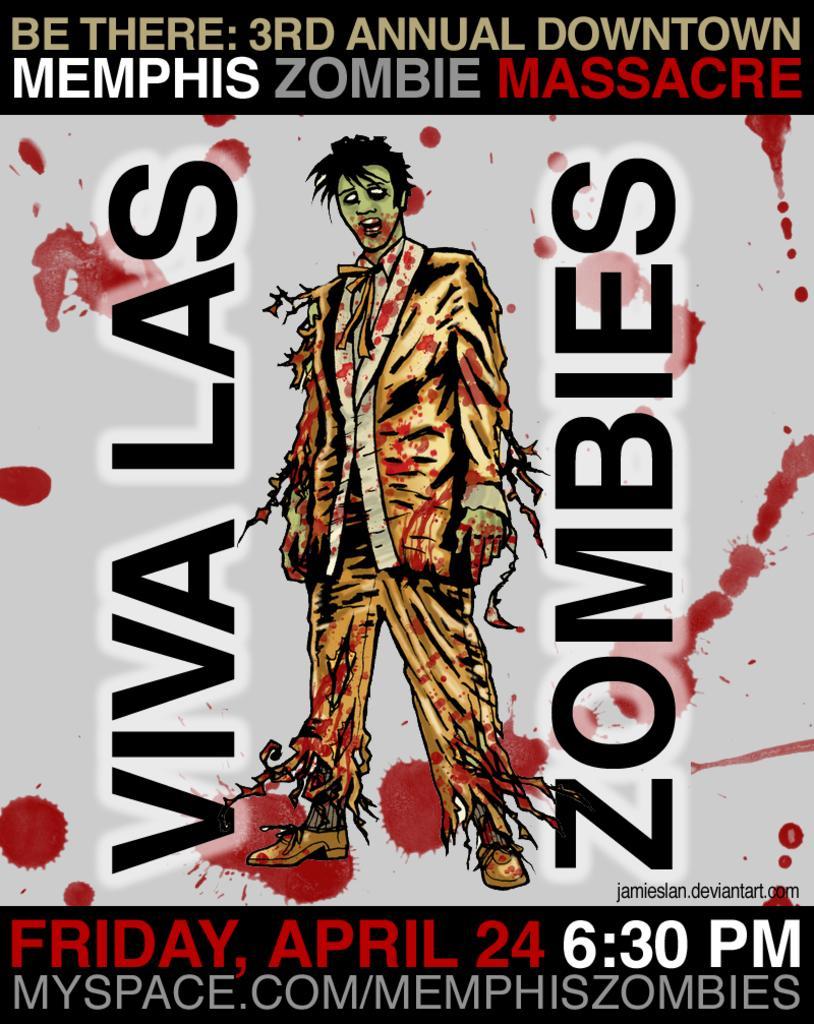How would you summarize this image in a sentence or two? Here we can see a poster. On this poster we can see picture of a person and text written on it. 